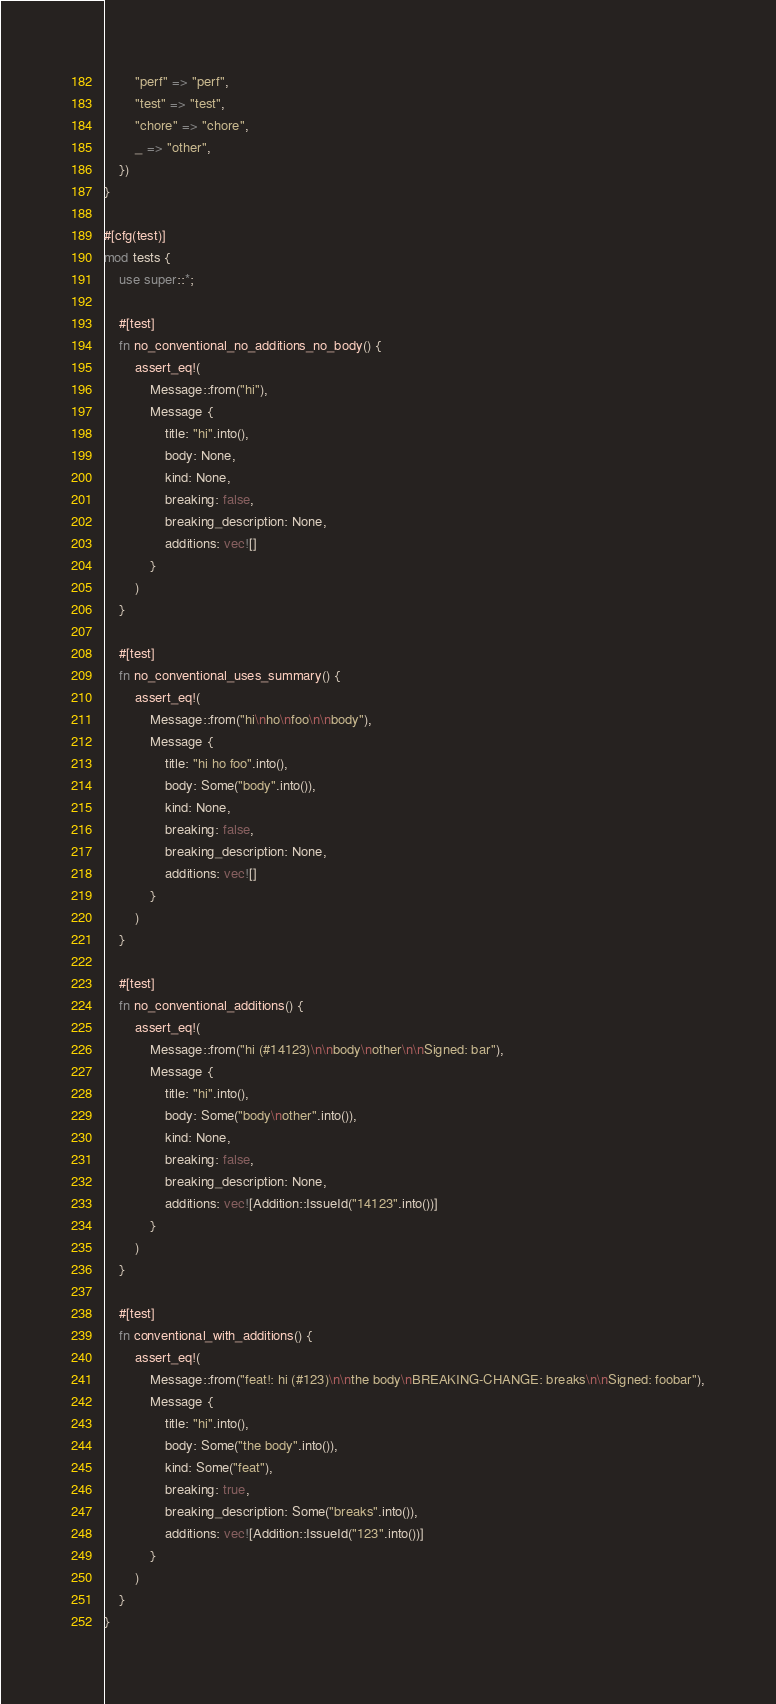<code> <loc_0><loc_0><loc_500><loc_500><_Rust_>        "perf" => "perf",
        "test" => "test",
        "chore" => "chore",
        _ => "other",
    })
}

#[cfg(test)]
mod tests {
    use super::*;

    #[test]
    fn no_conventional_no_additions_no_body() {
        assert_eq!(
            Message::from("hi"),
            Message {
                title: "hi".into(),
                body: None,
                kind: None,
                breaking: false,
                breaking_description: None,
                additions: vec![]
            }
        )
    }

    #[test]
    fn no_conventional_uses_summary() {
        assert_eq!(
            Message::from("hi\nho\nfoo\n\nbody"),
            Message {
                title: "hi ho foo".into(),
                body: Some("body".into()),
                kind: None,
                breaking: false,
                breaking_description: None,
                additions: vec![]
            }
        )
    }

    #[test]
    fn no_conventional_additions() {
        assert_eq!(
            Message::from("hi (#14123)\n\nbody\nother\n\nSigned: bar"),
            Message {
                title: "hi".into(),
                body: Some("body\nother".into()),
                kind: None,
                breaking: false,
                breaking_description: None,
                additions: vec![Addition::IssueId("14123".into())]
            }
        )
    }

    #[test]
    fn conventional_with_additions() {
        assert_eq!(
            Message::from("feat!: hi (#123)\n\nthe body\nBREAKING-CHANGE: breaks\n\nSigned: foobar"),
            Message {
                title: "hi".into(),
                body: Some("the body".into()),
                kind: Some("feat"),
                breaking: true,
                breaking_description: Some("breaks".into()),
                additions: vec![Addition::IssueId("123".into())]
            }
        )
    }
}
</code> 